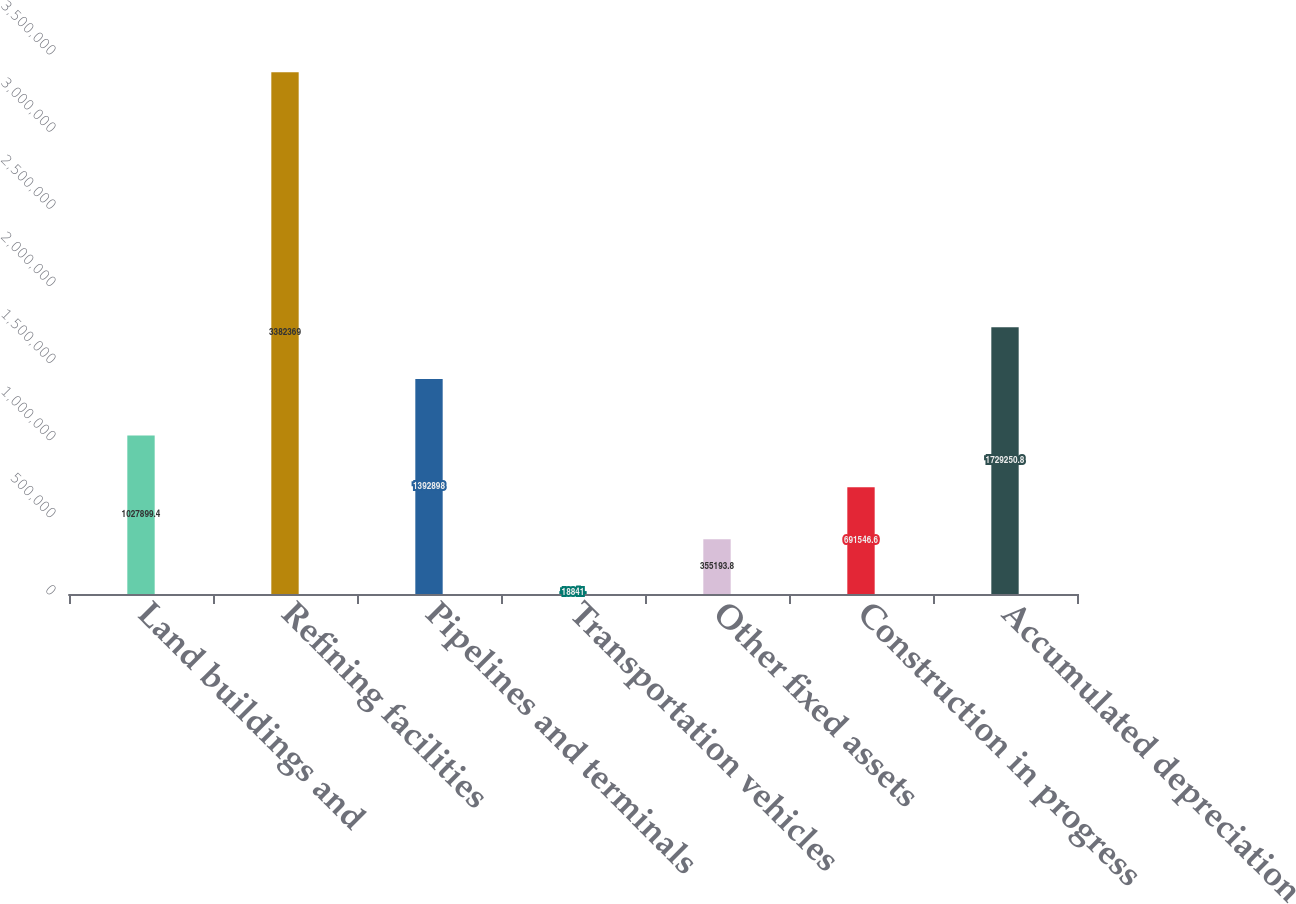Convert chart. <chart><loc_0><loc_0><loc_500><loc_500><bar_chart><fcel>Land buildings and<fcel>Refining facilities<fcel>Pipelines and terminals<fcel>Transportation vehicles<fcel>Other fixed assets<fcel>Construction in progress<fcel>Accumulated depreciation<nl><fcel>1.0279e+06<fcel>3.38237e+06<fcel>1.3929e+06<fcel>18841<fcel>355194<fcel>691547<fcel>1.72925e+06<nl></chart> 